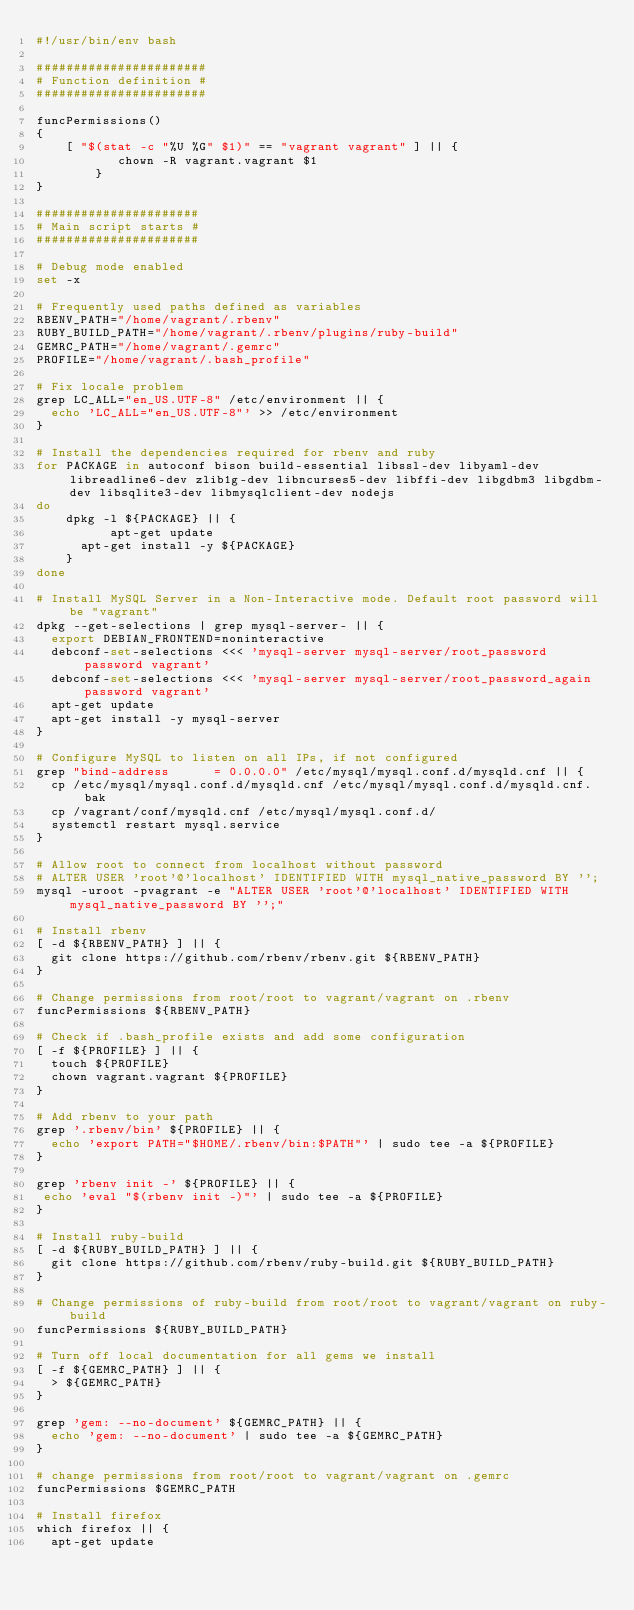Convert code to text. <code><loc_0><loc_0><loc_500><loc_500><_Bash_>#!/usr/bin/env bash

#######################
# Function definition #
#######################

funcPermissions()
{
	[ "$(stat -c "%U %G" $1)" == "vagrant vagrant" ] || {
           chown -R vagrant.vagrant $1
        }
}

######################
# Main script starts #
######################

# Debug mode enabled
set -x

# Frequently used paths defined as variables
RBENV_PATH="/home/vagrant/.rbenv"
RUBY_BUILD_PATH="/home/vagrant/.rbenv/plugins/ruby-build"
GEMRC_PATH="/home/vagrant/.gemrc"
PROFILE="/home/vagrant/.bash_profile"

# Fix locale problem
grep LC_ALL="en_US.UTF-8" /etc/environment || {
  echo 'LC_ALL="en_US.UTF-8"' >> /etc/environment
}

# Install the dependencies required for rbenv and ruby
for PACKAGE in autoconf bison build-essential libssl-dev libyaml-dev libreadline6-dev zlib1g-dev libncurses5-dev libffi-dev libgdbm3 libgdbm-dev libsqlite3-dev libmysqlclient-dev nodejs
do
	dpkg -l ${PACKAGE} || {
          apt-get update
	  apt-get install -y ${PACKAGE}
	}
done

# Install MySQL Server in a Non-Interactive mode. Default root password will be "vagrant"
dpkg --get-selections | grep mysql-server- || {
  export DEBIAN_FRONTEND=noninteractive
  debconf-set-selections <<< 'mysql-server mysql-server/root_password password vagrant'
  debconf-set-selections <<< 'mysql-server mysql-server/root_password_again password vagrant'
  apt-get update
  apt-get install -y mysql-server
}

# Configure MySQL to listen on all IPs, if not configured
grep "bind-address		= 0.0.0.0" /etc/mysql/mysql.conf.d/mysqld.cnf || {
  cp /etc/mysql/mysql.conf.d/mysqld.cnf /etc/mysql/mysql.conf.d/mysqld.cnf.bak
  cp /vagrant/conf/mysqld.cnf /etc/mysql/mysql.conf.d/
  systemctl restart mysql.service
}

# Allow root to connect from localhost without password
# ALTER USER 'root'@'localhost' IDENTIFIED WITH mysql_native_password BY '';
mysql -uroot -pvagrant -e "ALTER USER 'root'@'localhost' IDENTIFIED WITH mysql_native_password BY '';"

# Install rbenv
[ -d ${RBENV_PATH} ] || {
  git clone https://github.com/rbenv/rbenv.git ${RBENV_PATH}
}

# Change permissions from root/root to vagrant/vagrant on .rbenv
funcPermissions ${RBENV_PATH}

# Check if .bash_profile exists and add some configuration
[ -f ${PROFILE} ] || {
  touch ${PROFILE}
  chown vagrant.vagrant ${PROFILE}
}

# Add rbenv to your path
grep '.rbenv/bin' ${PROFILE} || {
  echo 'export PATH="$HOME/.rbenv/bin:$PATH"' | sudo tee -a ${PROFILE}
} 

grep 'rbenv init -' ${PROFILE} || {
 echo 'eval "$(rbenv init -)"' | sudo tee -a ${PROFILE}
}

# Install ruby-build
[ -d ${RUBY_BUILD_PATH} ] || {
  git clone https://github.com/rbenv/ruby-build.git ${RUBY_BUILD_PATH}
}

# Change permissions of ruby-build from root/root to vagrant/vagrant on ruby-build
funcPermissions ${RUBY_BUILD_PATH}

# Turn off local documentation for all gems we install
[ -f ${GEMRC_PATH} ] || {
  > ${GEMRC_PATH}
}

grep 'gem: --no-document' ${GEMRC_PATH} || {
  echo 'gem: --no-document' | sudo tee -a ${GEMRC_PATH}	
}

# change permissions from root/root to vagrant/vagrant on .gemrc
funcPermissions $GEMRC_PATH

# Install firefox
which firefox || {
  apt-get update</code> 